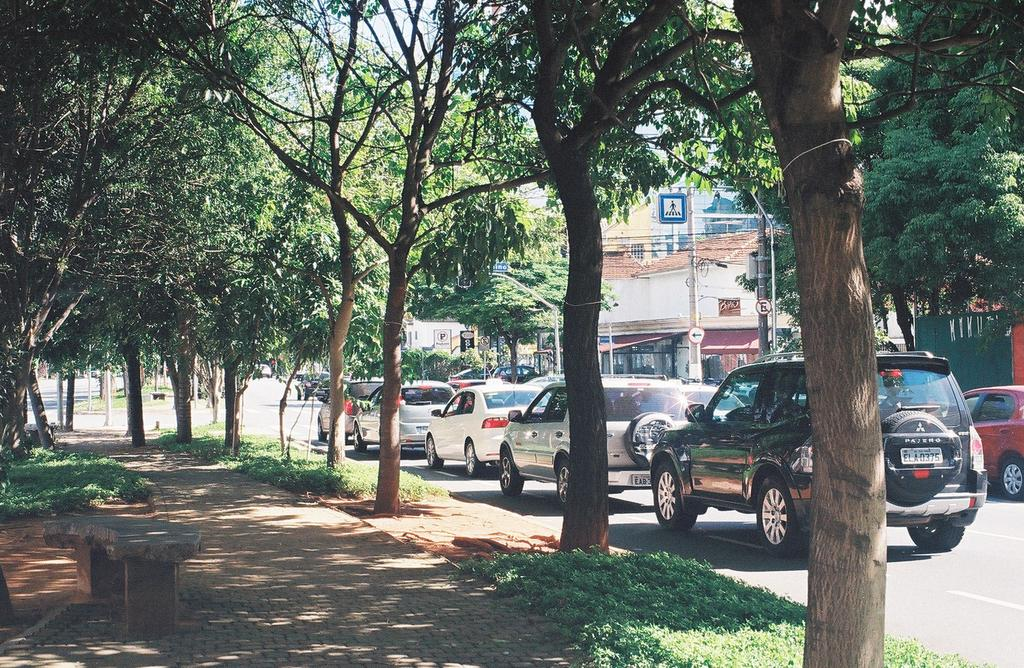What can be seen on the road in the image? There are vehicles on the road in the image. What type of vegetation is present in the image? There are trees in the image, and they are green. What type of structures can be seen in the image? There are stalls and buildings in the image. What colors are the buildings in the image? The buildings are white and cream colored. What is the color of the sky in the image? The sky is white in the image. How much profit did the paper make in the room in the image? There is no paper or room mentioned in the image, and therefore no profit can be associated with them. 